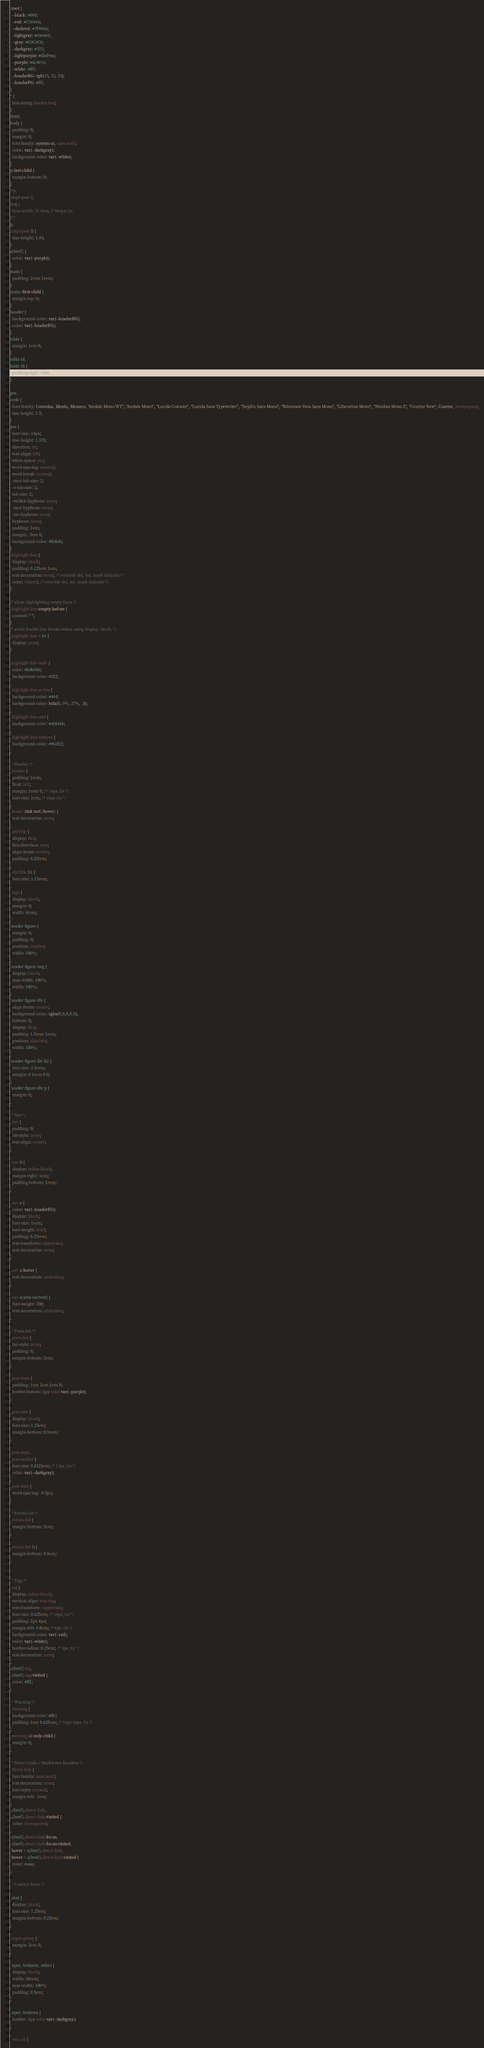Convert code to text. <code><loc_0><loc_0><loc_500><loc_500><_CSS_>:root {
  --black: #000;
  --red: #C5004A;
  --darkred: #7F0036;
  --lightgray: #e0e0e0;
  --gray: #C0C0C0;
  --darkgray: #333;
  --lightpurple: #dbd9ea;
  --purple: #6c407e;
  --white: #fff;
  --headerBG: rgb(33, 33, 33);
  --headerFG: #fff;
}
* {
  box-sizing: border-box;
}
html,
body {
  padding: 0;
  margin: 0;
  font-family: system-ui, sans-serif;
  color: var(--darkgray);
  background-color: var(--white);
}
p:last-child {
  margin-bottom: 0;
}
/*p,
.tmpl-post li,
img {
  max-width: 37.5em; /* 600px /16 
}*/
p,
.tmpl-post li {
  line-height: 1.45;
}
a[href] {
  color: var(--purple);
}
main {
  padding: 2rem 1rem;
}
main :first-child {
  margin-top: 0;
}
header {
  background-color: var(--headerBG);
  color: var(--headerFG);
}
table {
  margin: 1em 0;
}
table td,
table th {
  padding-right: 1em;
}

pre,
code {
  font-family: Consolas, Menlo, Monaco, "Andale Mono WT", "Andale Mono", "Lucida Console", "Lucida Sans Typewriter", "DejaVu Sans Mono", "Bitstream Vera Sans Mono", "Liberation Mono", "Nimbus Mono L", "Courier New", Courier, monospace;
  line-height: 1.5;
}
pre {
  font-size: 14px;
  line-height: 1.375;
  direction: ltr;
  text-align: left;
  white-space: pre;
  word-spacing: normal;
  word-break: normal;
  -moz-tab-size: 2;
  -o-tab-size: 2;
  tab-size: 2;
  -webkit-hyphens: none;
  -moz-hyphens: none;
  -ms-hyphens: none;
  hyphens: none;
  padding: 1em;
  margin: .5em 0;
  background-color: #f6f6f6;
}
.highlight-line {
  display: block;
  padding: 0.125em 1em;
  text-decoration: none; /* override del, ins, mark defaults */
  color: inherit; /* override del, ins, mark defaults */
}

/* allow highlighting empty lines */
.highlight-line:empty:before {
  content: " ";
}
/* avoid double line breaks when using display: block; */
.highlight-line + br {
  display: none;
}

.highlight-line-isdir {
  color: #b0b0b0;
  background-color: #222;
}
.highlight-line-active {
  background-color: #444;
  background-color: hsla(0, 0%, 27%, .8);
}
.highlight-line-add {
  background-color: #45844b;
}
.highlight-line-remove {
  background-color: #902f2f;
}

/* Header */
.header {
  padding: 1rem;
  float: left;
  margin: 1rem 0; /* 16px /16 */
  font-size: 1em; /* 16px /16 */
}
.home :link:not(:hover) {
  text-decoration: none;
}
.siteTitle {
  display: flex;
  flex-direction: row;
  align-items: center;
  padding: 0.25rem;
}
.siteTitle h1 {
  font-size: 1.25rem;
}
.logo {
  display: block;
  margin: 0;
  width: 4rem;
}
header figure {
  margin: 0;
  padding: 0;
  position: relative;
  width: 100%;
}
header figure img {
  display: block;
  max-width: 100%;
  width: 100%;
}
header figure div {
  align-items: center;
  background-color: rgba(0,0,0,0.5);
  bottom: 0;
  display: flex;
  padding: 1.5rem 1rem;
  position: absolute;
  width: 100%;
}
header figure div h2 {
  font-size: 2.5rem;
  margin: 0 1rem 0 0;
}
header figure div p {
  margin: 0;
}

/* Nav */
.nav {
  padding: 0;
  list-style: none;
  text-align: center;
}

.nav li {
  display: inline-block;
  margin-right: 1em;
  padding-bottom: 1rem;
}

.nav a {
  color: var(--headerFG);
  display: block;
  font-size: 1rem;
  font-weight: bold;
  padding: 0.25rem;
  text-transform: uppercase;
  text-decoration: none;
}

.nav a:hover {
  text-decoration: underline;
}

.nav a[aria-current] {
  font-weight: 700;
  text-decoration: underline;
}

/* Posts list */
.posts-list {
  list-style: none;
  padding: 0;
  margin-bottom: 2em;
}

.post-item {
  padding: 1em 1em 1em 0;
  border-bottom: 1px solid var(--purple);
}

.post-title {
  display: block;
  font-size: 1.25em;
  margin-bottom: 0.5rem;
}

.post-date,
.post-author {
  font-size: 0.8125em; /* 13px /16 */
  color: var(--darkgray);
}
.post-date {
  word-spacing: -0.5px;
}

/* Events list */
.events-list {
  margin-bottom: 2em;
}

.events-list li {
  margin-bottom: 0.5em;
}


/* Tags */
.tag {
  display: inline-block;
  vertical-align: text-top;
  text-transform: uppercase;
  font-size: 0.625em; /* 10px /16 */
  padding: 2px 4px;
  margin-left: 0.8em; /* 8px /10 */
  background-color: var(--red);
  color: var(--white);
  border-radius: 0.25em; /* 3px /12 */
  text-decoration: none;
}
a[href].tag,
a[href].tag:visited {
  color: #fff;
}

/* Warning */
.warning {
  background-color: #ffc;
  padding: 1em 0.625em; /* 16px 10px /16 */
}
.warning ol:only-child {
  margin: 0;
}

/* Direct Links / Markdown Headers */
.direct-link {
  font-family: sans-serif;
  text-decoration: none;
  font-style: normal;
  margin-left: .1em;
}
a[href].direct-link,
a[href].direct-link:visited {
  color: transparent;
}
a[href].direct-link:focus,
a[href].direct-link:focus:visited,
:hover > a[href].direct-link,
:hover > a[href].direct-link:visited {
  color: #aaa;
}

/* Contact Form */

label {
  display: block;
  font-size: 1.25em;
  margin-bottom: 0.25em;
}

.input-group {
  margin: 2em 0;
}

input, textarea, select {
  display: block;
  width: 30rem;
  max-width: 100%;
  padding: 0.5em;
}

input, textarea {
  border: 1px solid var(--darkgray);
}

.two-col {</code> 